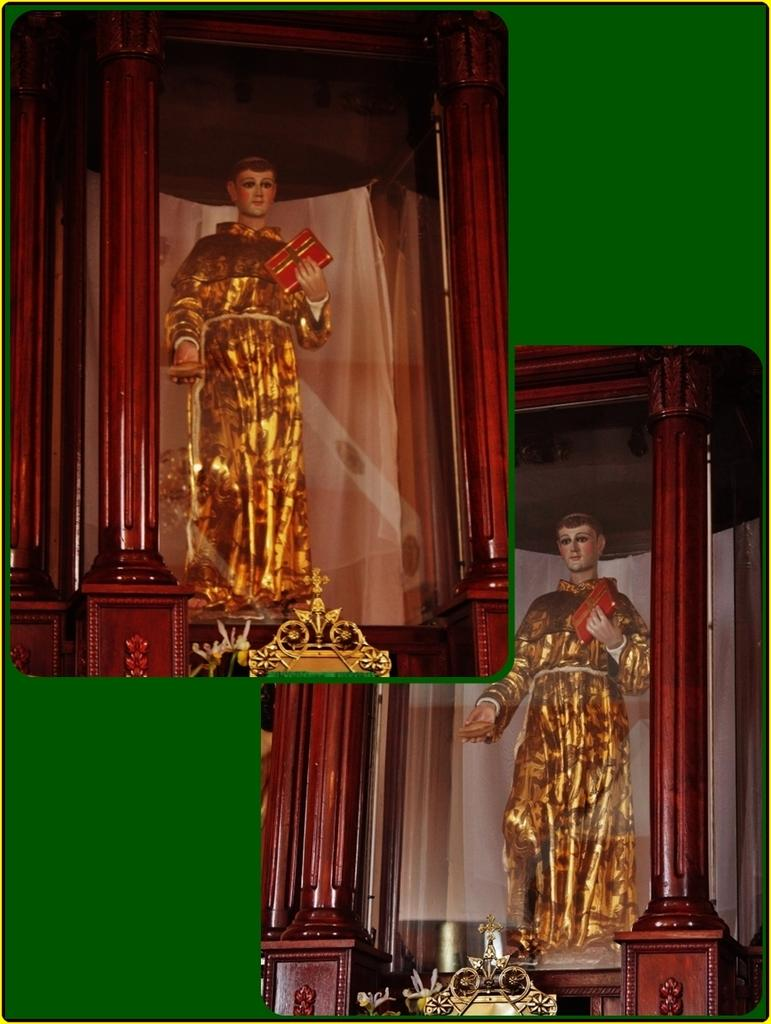What is the main subject of the image? The image is a collage of similar pictures. Can you describe one of the pictures in the collage? There is a statue of a man holding a book in the image. How is the statue displayed in the image? The statue is in a glass wooden box. What color is the background of the image? The background of the image is green. What type of stem can be seen growing from the side of the statue in the image? There is no stem growing from the side of the statue in the image; it is a statue of a man holding a book. In which direction is the statue facing in the image? The image is a collage of similar pictures, and it is not possible to determine the direction the statue is facing in each individual picture. 